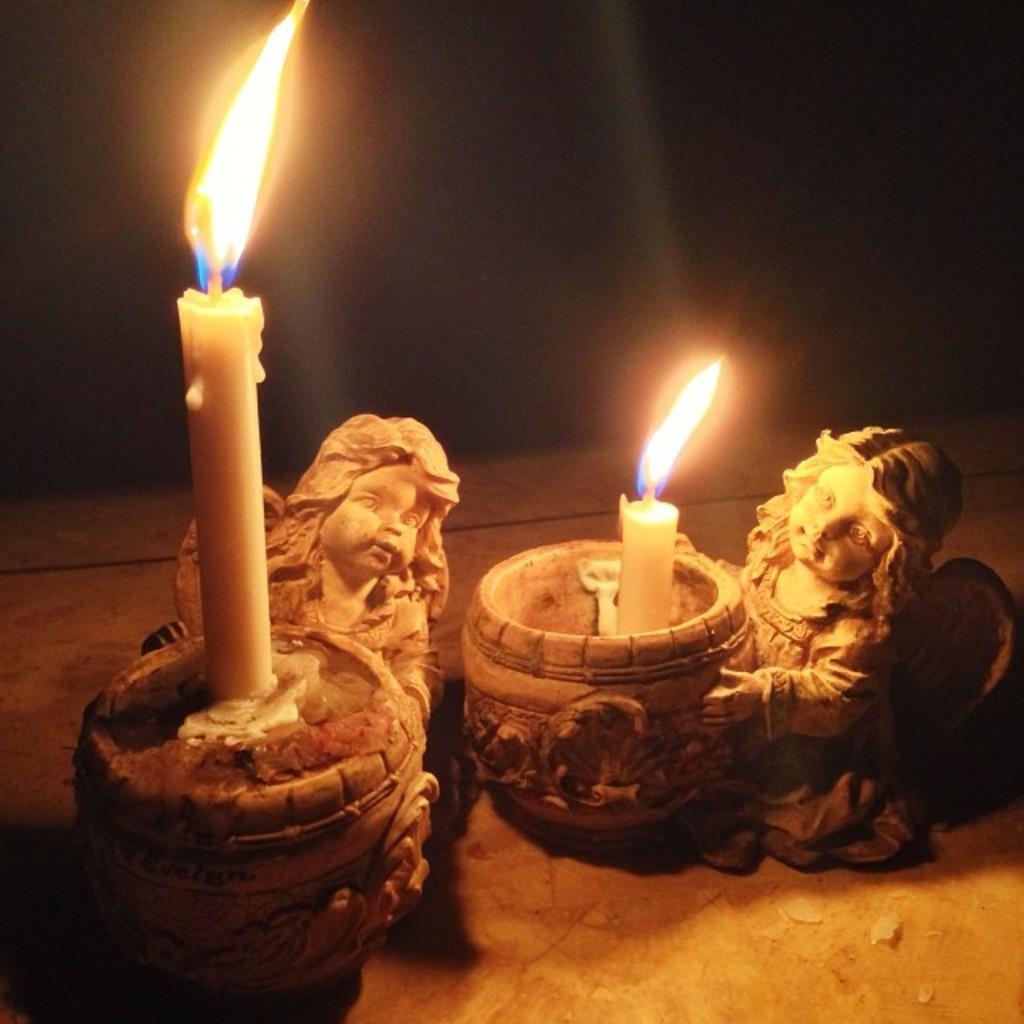What objects are present in the image that resemble statues? There are two statue candle holders in the image. Where are the statue candle holders located? The statue candle holders are present on a surface. What type of leather material can be seen on the statue candle holders in the image? There is no leather material present on the statue candle holders in the image. How many balls are visible in the image? There are no balls present in the image. 